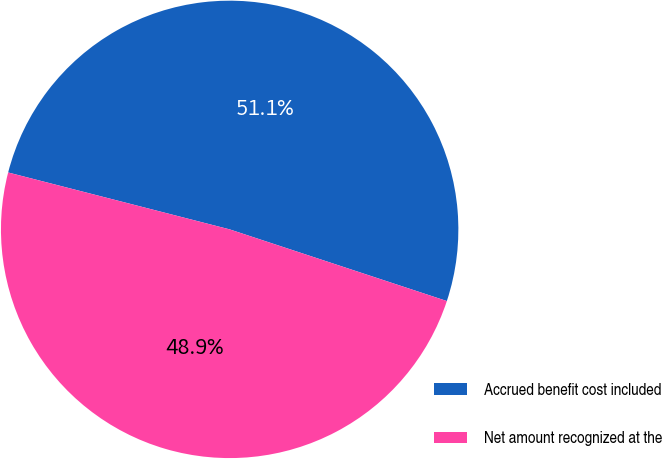Convert chart. <chart><loc_0><loc_0><loc_500><loc_500><pie_chart><fcel>Accrued benefit cost included<fcel>Net amount recognized at the<nl><fcel>51.07%<fcel>48.93%<nl></chart> 